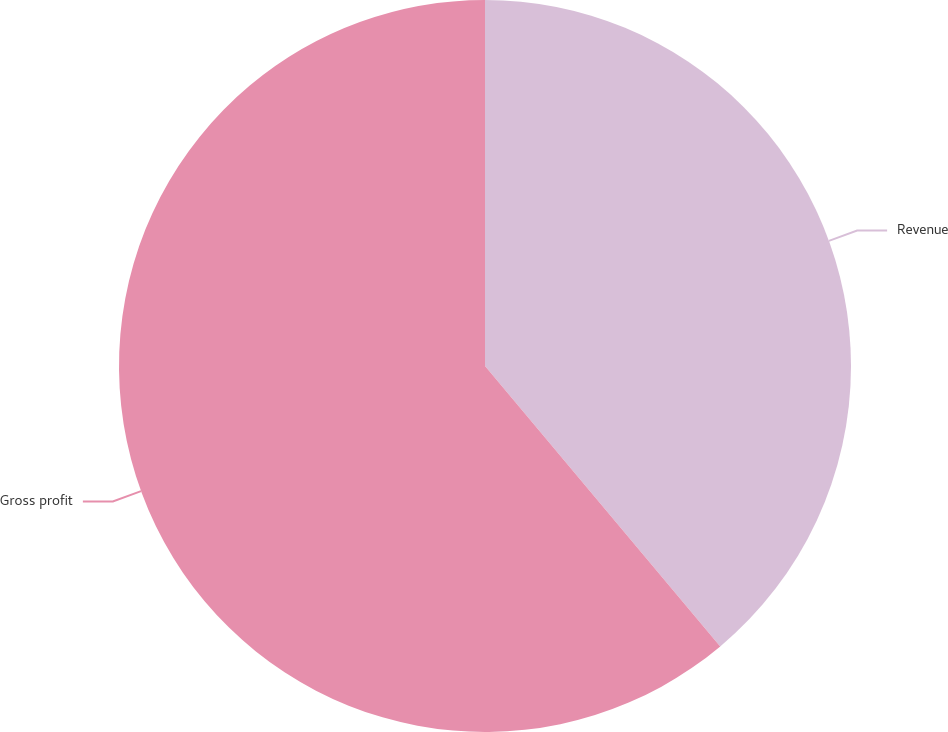Convert chart to OTSL. <chart><loc_0><loc_0><loc_500><loc_500><pie_chart><fcel>Revenue<fcel>Gross profit<nl><fcel>38.89%<fcel>61.11%<nl></chart> 